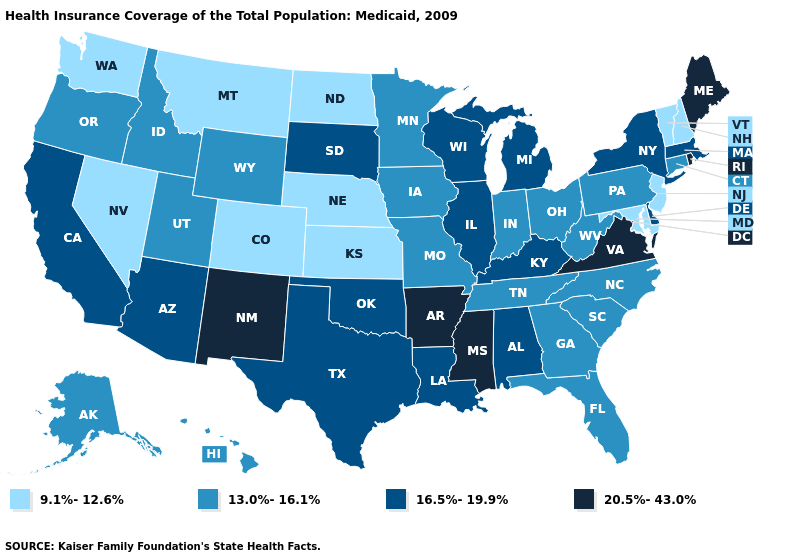What is the value of Massachusetts?
Give a very brief answer. 16.5%-19.9%. What is the value of Vermont?
Keep it brief. 9.1%-12.6%. How many symbols are there in the legend?
Give a very brief answer. 4. Which states hav the highest value in the South?
Be succinct. Arkansas, Mississippi, Virginia. What is the value of New Jersey?
Short answer required. 9.1%-12.6%. Among the states that border Oregon , does Idaho have the lowest value?
Short answer required. No. Name the states that have a value in the range 20.5%-43.0%?
Write a very short answer. Arkansas, Maine, Mississippi, New Mexico, Rhode Island, Virginia. Is the legend a continuous bar?
Short answer required. No. How many symbols are there in the legend?
Answer briefly. 4. Name the states that have a value in the range 13.0%-16.1%?
Give a very brief answer. Alaska, Connecticut, Florida, Georgia, Hawaii, Idaho, Indiana, Iowa, Minnesota, Missouri, North Carolina, Ohio, Oregon, Pennsylvania, South Carolina, Tennessee, Utah, West Virginia, Wyoming. Does Tennessee have the same value as Nebraska?
Concise answer only. No. Is the legend a continuous bar?
Short answer required. No. What is the highest value in the USA?
Short answer required. 20.5%-43.0%. What is the value of Georgia?
Short answer required. 13.0%-16.1%. Does Connecticut have a lower value than Washington?
Be succinct. No. 